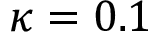<formula> <loc_0><loc_0><loc_500><loc_500>\kappa = 0 . 1</formula> 